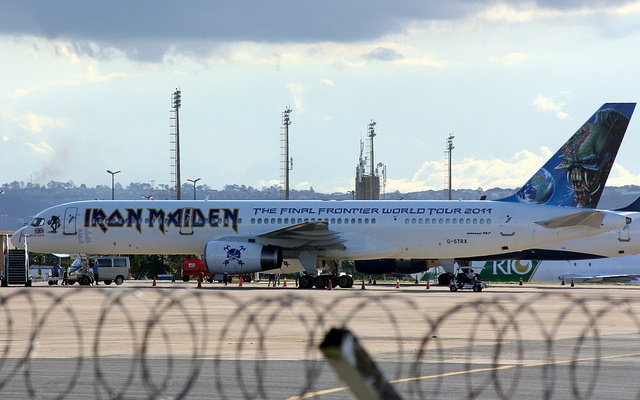Describe the objects in this image and their specific colors. I can see airplane in darkgray, gray, and black tones, truck in darkgray, black, gray, navy, and blue tones, truck in darkgray, maroon, black, and gray tones, people in darkgray, black, navy, purple, and blue tones, and people in darkgray, black, navy, gray, and darkblue tones in this image. 